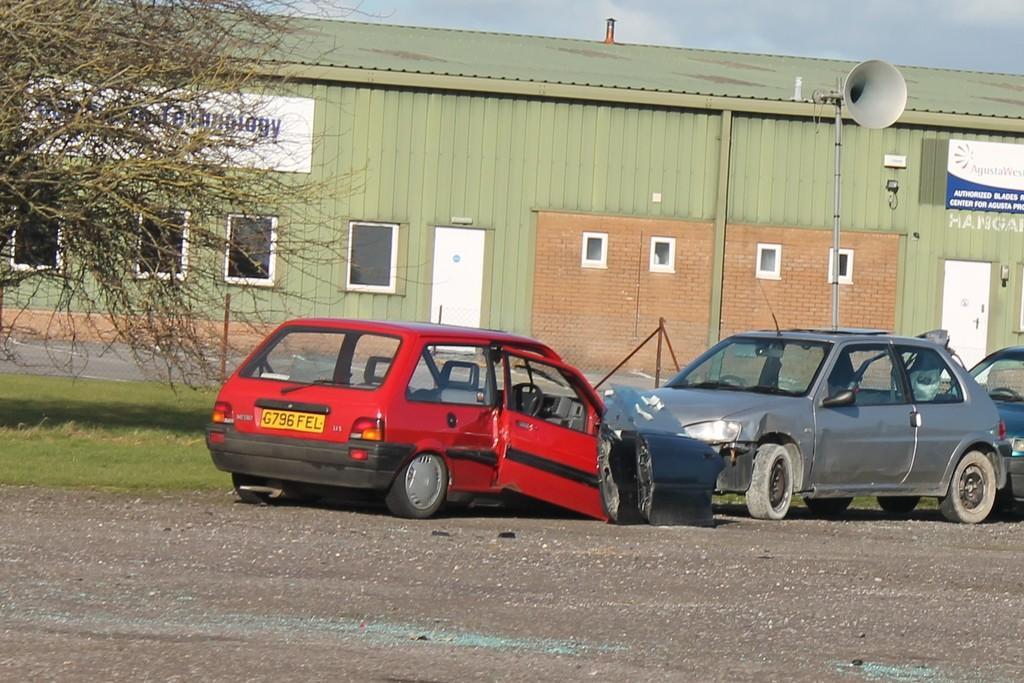Please provide a concise description of this image. In this image we can see cars on the ground. Here we can see grass, branches, boards, windows, doors, shed, and a pole. In the background there is sky. 